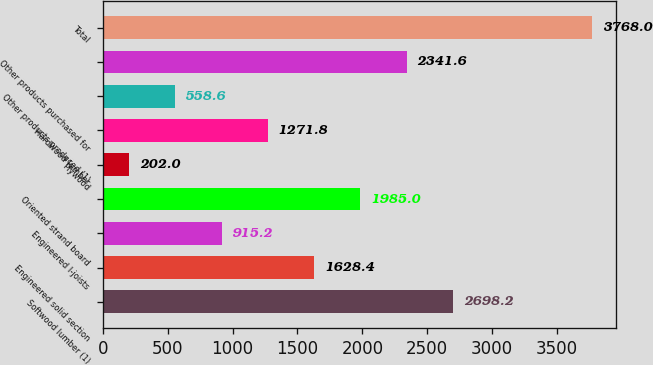<chart> <loc_0><loc_0><loc_500><loc_500><bar_chart><fcel>Softwood lumber (1)<fcel>Engineered solid section<fcel>Engineered I-joists<fcel>Oriented strand board<fcel>Plywood<fcel>Hardwood lumber<fcel>Other products produced (1)<fcel>Other products purchased for<fcel>Total<nl><fcel>2698.2<fcel>1628.4<fcel>915.2<fcel>1985<fcel>202<fcel>1271.8<fcel>558.6<fcel>2341.6<fcel>3768<nl></chart> 